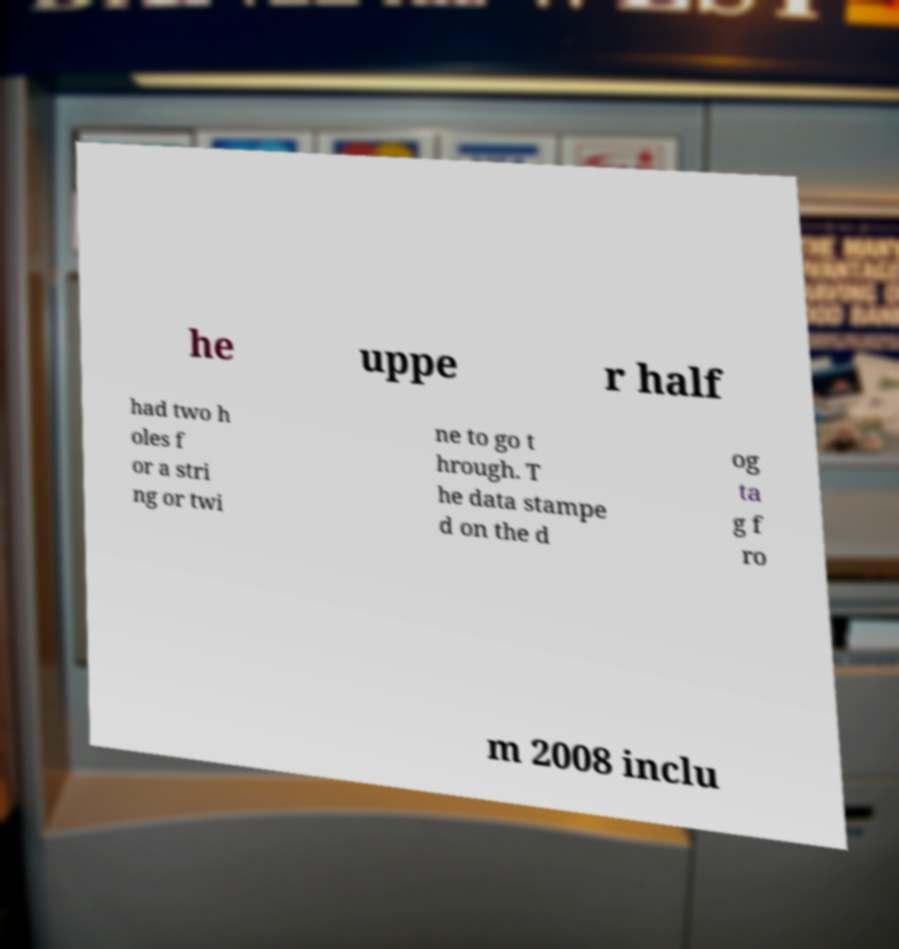Can you accurately transcribe the text from the provided image for me? he uppe r half had two h oles f or a stri ng or twi ne to go t hrough. T he data stampe d on the d og ta g f ro m 2008 inclu 